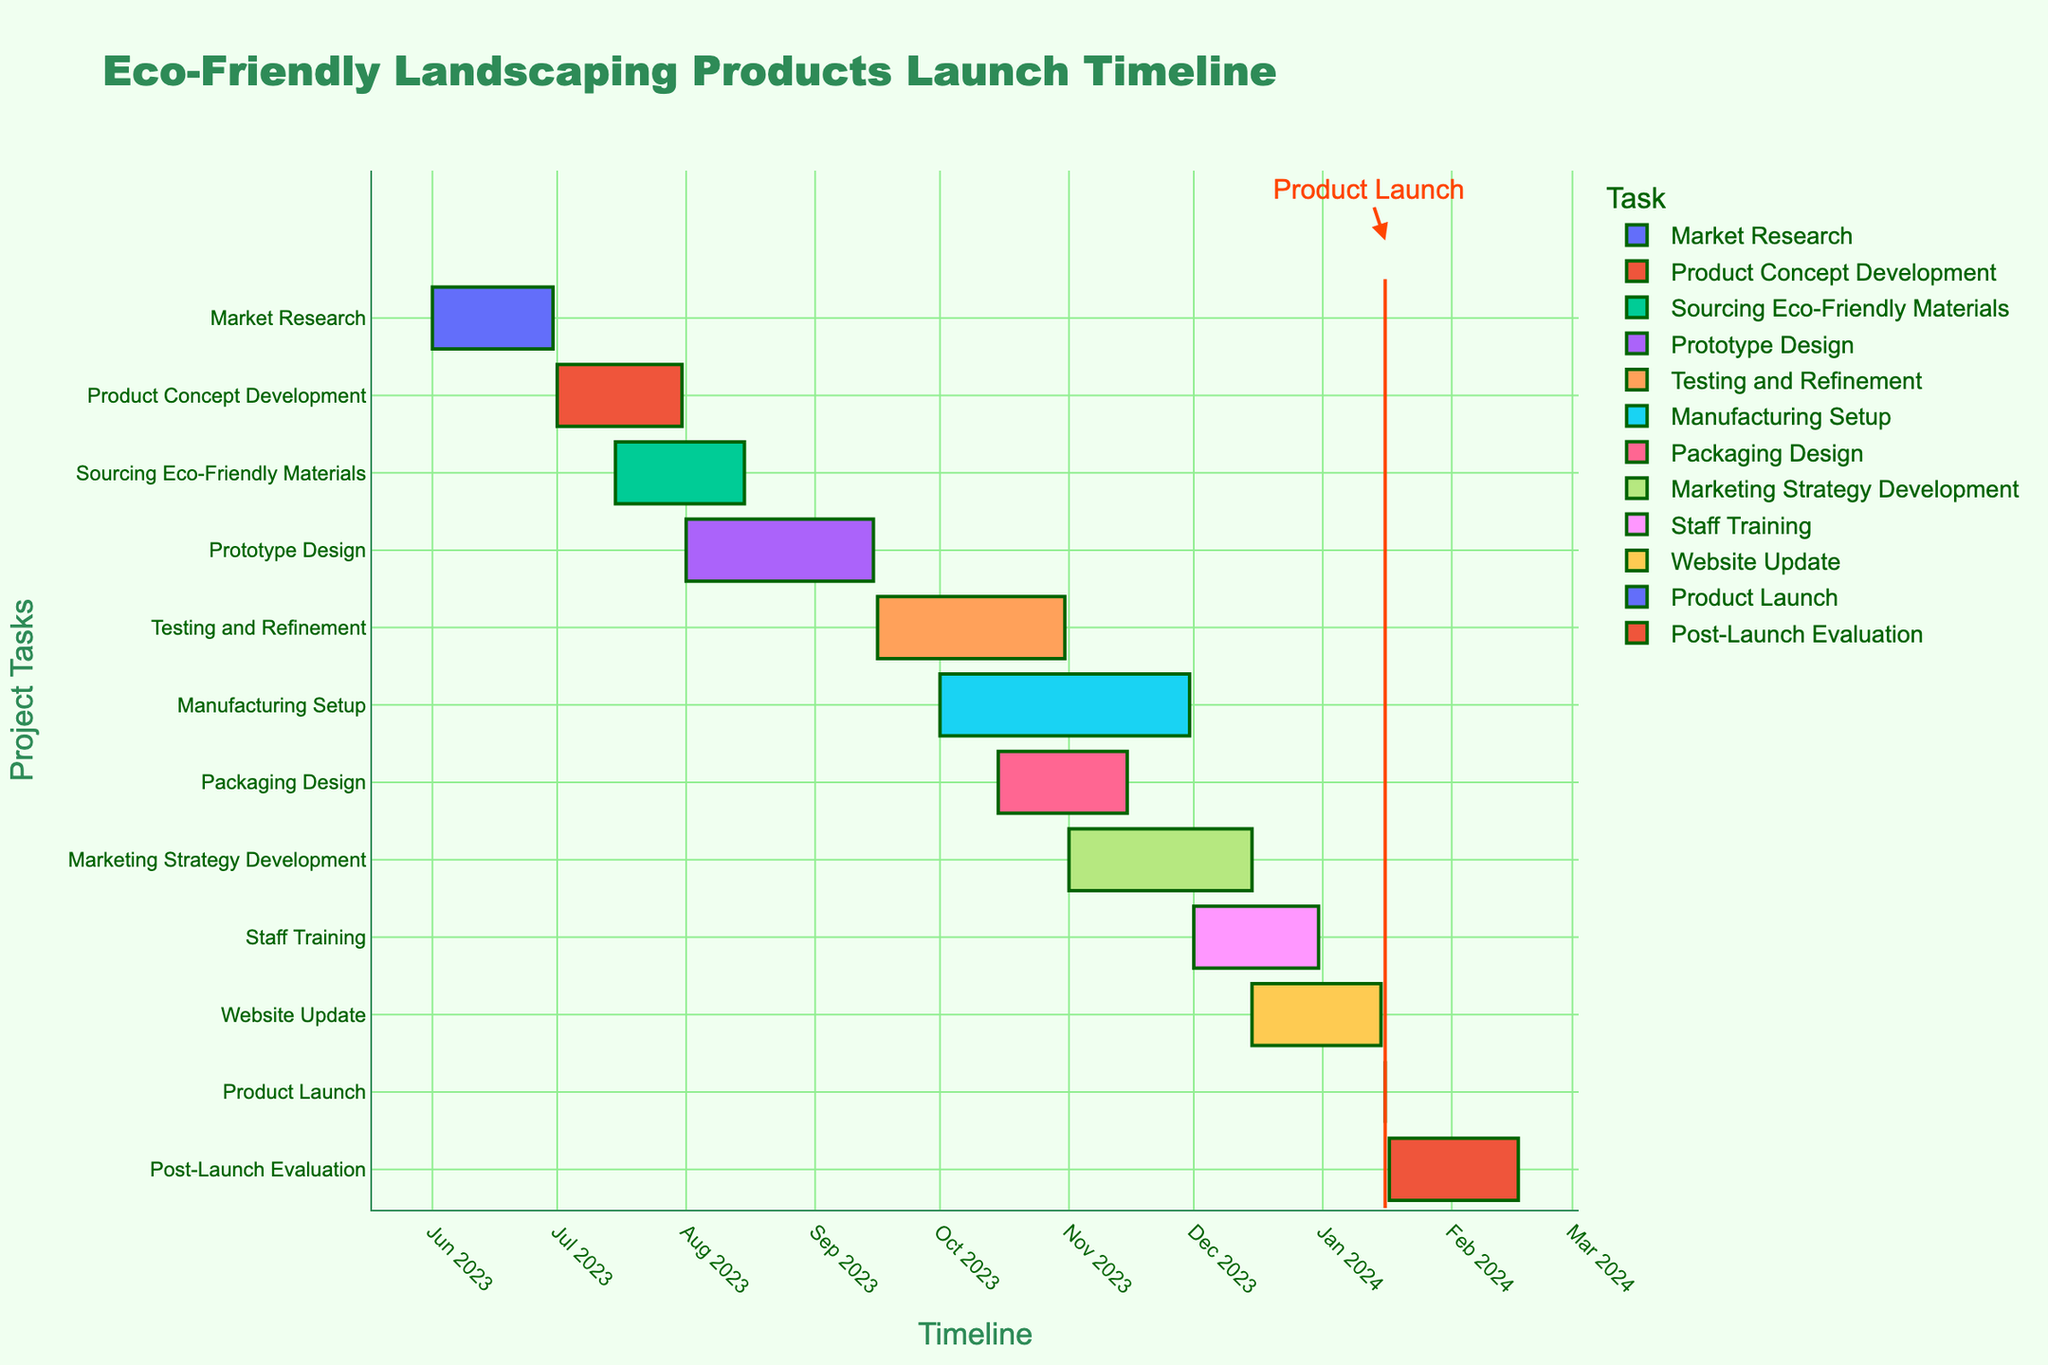What is the title of the Gantt chart? The title of the Gantt chart is shown at the top of the figure. It states "Eco-Friendly Landscaping Products Launch Timeline".
Answer: "Eco-Friendly Landscaping Products Launch Timeline" What is the duration of the 'Prototype Design' task? The duration of the 'Prototype Design' task is highlighted by the length of its bar. The hover data or the duration column in the data also indicates a duration of 46 days.
Answer: 46 days Which task has the longest duration, and how long is it? The task with the longest duration has the longest corresponding bar on the Gantt chart. 'Manufacturing Setup' has the longest bar and its duration is shown as 61 days.
Answer: 'Manufacturing Setup', 61 days In which month does the 'Product Launch' occur? The 'Product Launch' is marked clearly on the chart with a highlighted rectangle on a specific date. The annotation also indicates that the launch occurs on January 16, 2024.
Answer: January 2024 What is the duration of the entire project from 'Market Research' to 'Post-Launch Evaluation'? To calculate the total project duration, we note the start and end dates of the first and last tasks. 'Market Research' starts on June 1, 2023, and 'Post-Launch Evaluation' ends on February 17, 2024. Calculating the difference between these dates gives the total duration. From June 1, 2023, to February 17, 2024, is 262 days.
Answer: 262 days What is the overlap period between 'Sourcing Eco-Friendly Materials' and 'Prototype Design'? Identify the overlapping dates between 'Sourcing Eco-Friendly Materials' (July 15, 2023, to August 15, 2023) and 'Prototype Design' (August 1, 2023, to September 15, 2023). The overlap is from August 1, 2023, to August 15, 2023, which is 15 days.
Answer: 15 days Which tasks are scheduled to start in December 2023? By examining the starting dates of all tasks in the Gantt chart, the tasks starting in December 2023 are 'Staff Training' on December 1, and 'Website Update' on December 15.
Answer: 'Staff Training' and 'Website Update' Do 'Testing and Refinement' and 'Packaging Design' occur simultaneously at any point? Compare the time frames of 'Testing and Refinement' (September 16, 2023, to October 31, 2023) and 'Packaging Design' (October 15, 2023, to November 15, 2023). There is an overlap from October 15, 2023, to October 31, 2023.
Answer: Yes Which task immediately follows the 'Prototype Design'? By observing the timeline, the task that begins right after the end of 'Prototype Design' is 'Testing and Refinement', which starts on September 16, 2023.
Answer: 'Testing and Refinement' 